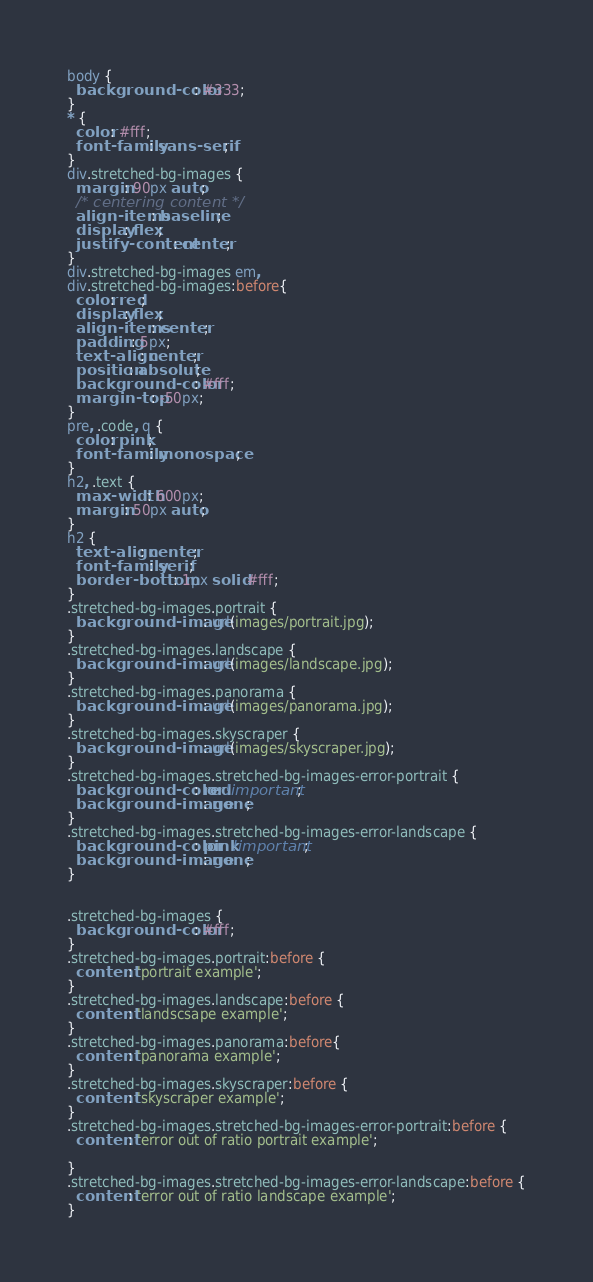<code> <loc_0><loc_0><loc_500><loc_500><_CSS_>body {
  background-color: #333;
}
* {
  color: #fff;
  font-family: sans-serif;
}
div.stretched-bg-images {
  margin: 90px auto;
  /* centering content */
  align-items: baseline;
  display: flex;
  justify-content: center;
}
div.stretched-bg-images em,
div.stretched-bg-images:before{
  color: red;
  display: flex;
  align-items: center;
  padding: 5px;
  text-align: center;
  position: absolute;
  background-color: #fff;
  margin-top: -50px;
}
pre, .code, q {
  color: pink;
  font-family: monospace;
}
h2, .text {
  max-width: 600px;
  margin: 50px auto;
}
h2 {
  text-align: center;
  font-family: serif;
  border-bottom: 1px solid #fff;
}
.stretched-bg-images.portrait {
  background-image: url(images/portrait.jpg);
}
.stretched-bg-images.landscape {
  background-image: url(images/landscape.jpg);
}
.stretched-bg-images.panorama {
  background-image: url(images/panorama.jpg);
}
.stretched-bg-images.skyscraper {
  background-image: url(images/skyscraper.jpg);
}
.stretched-bg-images.stretched-bg-images-error-portrait {
  background-color: red!important;
  background-image: none;
}
.stretched-bg-images.stretched-bg-images-error-landscape {
  background-color: pink!important;
  background-image: none;
}


.stretched-bg-images {
  background-color: #fff;
}
.stretched-bg-images.portrait:before {
  content: 'portrait example';
}
.stretched-bg-images.landscape:before {
  content: 'landscsape example';
}
.stretched-bg-images.panorama:before{
  content: 'panorama example';
}
.stretched-bg-images.skyscraper:before {
  content: 'skyscraper example';
}
.stretched-bg-images.stretched-bg-images-error-portrait:before {
  content: 'error out of ratio portrait example';

}
.stretched-bg-images.stretched-bg-images-error-landscape:before {
  content: 'error out of ratio landscape example';
}
</code> 